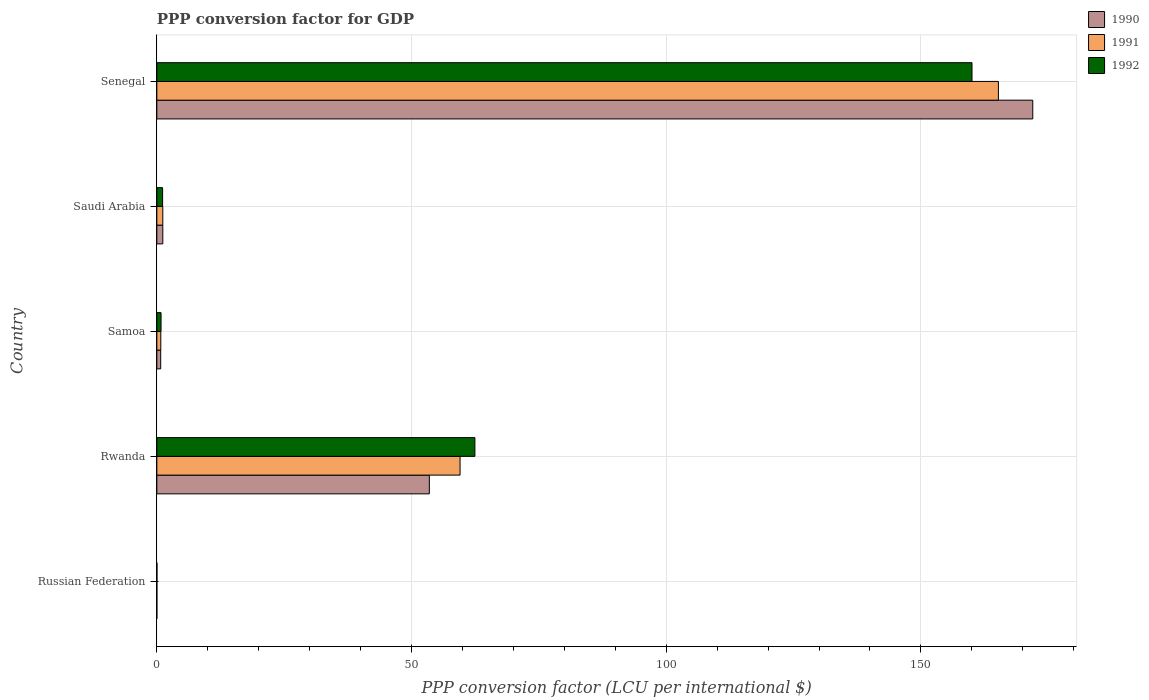How many different coloured bars are there?
Your response must be concise. 3. How many groups of bars are there?
Ensure brevity in your answer.  5. Are the number of bars per tick equal to the number of legend labels?
Your response must be concise. Yes. Are the number of bars on each tick of the Y-axis equal?
Make the answer very short. Yes. What is the label of the 1st group of bars from the top?
Provide a short and direct response. Senegal. What is the PPP conversion factor for GDP in 1991 in Saudi Arabia?
Make the answer very short. 1.17. Across all countries, what is the maximum PPP conversion factor for GDP in 1990?
Your response must be concise. 171.97. Across all countries, what is the minimum PPP conversion factor for GDP in 1991?
Ensure brevity in your answer.  0. In which country was the PPP conversion factor for GDP in 1992 maximum?
Provide a succinct answer. Senegal. In which country was the PPP conversion factor for GDP in 1991 minimum?
Your answer should be compact. Russian Federation. What is the total PPP conversion factor for GDP in 1992 in the graph?
Provide a succinct answer. 224.46. What is the difference between the PPP conversion factor for GDP in 1990 in Saudi Arabia and that in Senegal?
Your answer should be compact. -170.8. What is the difference between the PPP conversion factor for GDP in 1990 in Russian Federation and the PPP conversion factor for GDP in 1992 in Rwanda?
Keep it short and to the point. -62.44. What is the average PPP conversion factor for GDP in 1991 per country?
Provide a short and direct response. 45.34. What is the difference between the PPP conversion factor for GDP in 1992 and PPP conversion factor for GDP in 1990 in Rwanda?
Offer a terse response. 8.94. What is the ratio of the PPP conversion factor for GDP in 1990 in Russian Federation to that in Samoa?
Your response must be concise. 0. What is the difference between the highest and the second highest PPP conversion factor for GDP in 1992?
Give a very brief answer. 97.6. What is the difference between the highest and the lowest PPP conversion factor for GDP in 1990?
Offer a very short reply. 171.97. In how many countries, is the PPP conversion factor for GDP in 1990 greater than the average PPP conversion factor for GDP in 1990 taken over all countries?
Provide a succinct answer. 2. Is the sum of the PPP conversion factor for GDP in 1991 in Russian Federation and Senegal greater than the maximum PPP conversion factor for GDP in 1992 across all countries?
Your answer should be compact. Yes. What does the 3rd bar from the top in Samoa represents?
Your response must be concise. 1990. What does the 1st bar from the bottom in Senegal represents?
Provide a succinct answer. 1990. Is it the case that in every country, the sum of the PPP conversion factor for GDP in 1991 and PPP conversion factor for GDP in 1992 is greater than the PPP conversion factor for GDP in 1990?
Offer a terse response. Yes. How many bars are there?
Offer a very short reply. 15. How many countries are there in the graph?
Keep it short and to the point. 5. What is the difference between two consecutive major ticks on the X-axis?
Ensure brevity in your answer.  50. Are the values on the major ticks of X-axis written in scientific E-notation?
Ensure brevity in your answer.  No. Does the graph contain grids?
Provide a succinct answer. Yes. How are the legend labels stacked?
Make the answer very short. Vertical. What is the title of the graph?
Provide a short and direct response. PPP conversion factor for GDP. What is the label or title of the X-axis?
Ensure brevity in your answer.  PPP conversion factor (LCU per international $). What is the label or title of the Y-axis?
Provide a succinct answer. Country. What is the PPP conversion factor (LCU per international $) in 1990 in Russian Federation?
Make the answer very short. 0. What is the PPP conversion factor (LCU per international $) in 1991 in Russian Federation?
Provide a succinct answer. 0. What is the PPP conversion factor (LCU per international $) in 1992 in Russian Federation?
Provide a succinct answer. 0.02. What is the PPP conversion factor (LCU per international $) of 1990 in Rwanda?
Provide a short and direct response. 53.5. What is the PPP conversion factor (LCU per international $) in 1991 in Rwanda?
Keep it short and to the point. 59.53. What is the PPP conversion factor (LCU per international $) in 1992 in Rwanda?
Keep it short and to the point. 62.44. What is the PPP conversion factor (LCU per international $) in 1990 in Samoa?
Offer a terse response. 0.76. What is the PPP conversion factor (LCU per international $) of 1991 in Samoa?
Your response must be concise. 0.78. What is the PPP conversion factor (LCU per international $) of 1992 in Samoa?
Make the answer very short. 0.82. What is the PPP conversion factor (LCU per international $) of 1990 in Saudi Arabia?
Your response must be concise. 1.17. What is the PPP conversion factor (LCU per international $) in 1991 in Saudi Arabia?
Offer a terse response. 1.17. What is the PPP conversion factor (LCU per international $) in 1992 in Saudi Arabia?
Offer a very short reply. 1.13. What is the PPP conversion factor (LCU per international $) in 1990 in Senegal?
Offer a very short reply. 171.97. What is the PPP conversion factor (LCU per international $) in 1991 in Senegal?
Your answer should be compact. 165.22. What is the PPP conversion factor (LCU per international $) of 1992 in Senegal?
Make the answer very short. 160.04. Across all countries, what is the maximum PPP conversion factor (LCU per international $) of 1990?
Your response must be concise. 171.97. Across all countries, what is the maximum PPP conversion factor (LCU per international $) in 1991?
Offer a very short reply. 165.22. Across all countries, what is the maximum PPP conversion factor (LCU per international $) of 1992?
Your answer should be compact. 160.04. Across all countries, what is the minimum PPP conversion factor (LCU per international $) in 1990?
Your answer should be very brief. 0. Across all countries, what is the minimum PPP conversion factor (LCU per international $) of 1991?
Give a very brief answer. 0. Across all countries, what is the minimum PPP conversion factor (LCU per international $) in 1992?
Give a very brief answer. 0.02. What is the total PPP conversion factor (LCU per international $) in 1990 in the graph?
Provide a short and direct response. 227.39. What is the total PPP conversion factor (LCU per international $) of 1991 in the graph?
Ensure brevity in your answer.  226.7. What is the total PPP conversion factor (LCU per international $) of 1992 in the graph?
Offer a terse response. 224.46. What is the difference between the PPP conversion factor (LCU per international $) of 1990 in Russian Federation and that in Rwanda?
Give a very brief answer. -53.5. What is the difference between the PPP conversion factor (LCU per international $) of 1991 in Russian Federation and that in Rwanda?
Provide a short and direct response. -59.53. What is the difference between the PPP conversion factor (LCU per international $) in 1992 in Russian Federation and that in Rwanda?
Ensure brevity in your answer.  -62.42. What is the difference between the PPP conversion factor (LCU per international $) of 1990 in Russian Federation and that in Samoa?
Ensure brevity in your answer.  -0.76. What is the difference between the PPP conversion factor (LCU per international $) of 1991 in Russian Federation and that in Samoa?
Offer a terse response. -0.78. What is the difference between the PPP conversion factor (LCU per international $) of 1992 in Russian Federation and that in Samoa?
Offer a terse response. -0.81. What is the difference between the PPP conversion factor (LCU per international $) of 1990 in Russian Federation and that in Saudi Arabia?
Give a very brief answer. -1.17. What is the difference between the PPP conversion factor (LCU per international $) of 1991 in Russian Federation and that in Saudi Arabia?
Make the answer very short. -1.17. What is the difference between the PPP conversion factor (LCU per international $) in 1992 in Russian Federation and that in Saudi Arabia?
Your response must be concise. -1.11. What is the difference between the PPP conversion factor (LCU per international $) of 1990 in Russian Federation and that in Senegal?
Make the answer very short. -171.97. What is the difference between the PPP conversion factor (LCU per international $) of 1991 in Russian Federation and that in Senegal?
Make the answer very short. -165.22. What is the difference between the PPP conversion factor (LCU per international $) of 1992 in Russian Federation and that in Senegal?
Offer a terse response. -160.02. What is the difference between the PPP conversion factor (LCU per international $) in 1990 in Rwanda and that in Samoa?
Offer a very short reply. 52.74. What is the difference between the PPP conversion factor (LCU per international $) in 1991 in Rwanda and that in Samoa?
Provide a succinct answer. 58.75. What is the difference between the PPP conversion factor (LCU per international $) of 1992 in Rwanda and that in Samoa?
Provide a succinct answer. 61.62. What is the difference between the PPP conversion factor (LCU per international $) in 1990 in Rwanda and that in Saudi Arabia?
Your answer should be compact. 52.33. What is the difference between the PPP conversion factor (LCU per international $) in 1991 in Rwanda and that in Saudi Arabia?
Your answer should be compact. 58.36. What is the difference between the PPP conversion factor (LCU per international $) of 1992 in Rwanda and that in Saudi Arabia?
Give a very brief answer. 61.31. What is the difference between the PPP conversion factor (LCU per international $) of 1990 in Rwanda and that in Senegal?
Your response must be concise. -118.47. What is the difference between the PPP conversion factor (LCU per international $) in 1991 in Rwanda and that in Senegal?
Offer a very short reply. -105.69. What is the difference between the PPP conversion factor (LCU per international $) in 1992 in Rwanda and that in Senegal?
Provide a short and direct response. -97.6. What is the difference between the PPP conversion factor (LCU per international $) of 1990 in Samoa and that in Saudi Arabia?
Offer a very short reply. -0.41. What is the difference between the PPP conversion factor (LCU per international $) of 1991 in Samoa and that in Saudi Arabia?
Keep it short and to the point. -0.39. What is the difference between the PPP conversion factor (LCU per international $) in 1992 in Samoa and that in Saudi Arabia?
Give a very brief answer. -0.31. What is the difference between the PPP conversion factor (LCU per international $) in 1990 in Samoa and that in Senegal?
Offer a terse response. -171.21. What is the difference between the PPP conversion factor (LCU per international $) of 1991 in Samoa and that in Senegal?
Offer a terse response. -164.45. What is the difference between the PPP conversion factor (LCU per international $) in 1992 in Samoa and that in Senegal?
Provide a short and direct response. -159.21. What is the difference between the PPP conversion factor (LCU per international $) in 1990 in Saudi Arabia and that in Senegal?
Your answer should be very brief. -170.8. What is the difference between the PPP conversion factor (LCU per international $) of 1991 in Saudi Arabia and that in Senegal?
Your response must be concise. -164.05. What is the difference between the PPP conversion factor (LCU per international $) of 1992 in Saudi Arabia and that in Senegal?
Your answer should be compact. -158.91. What is the difference between the PPP conversion factor (LCU per international $) of 1990 in Russian Federation and the PPP conversion factor (LCU per international $) of 1991 in Rwanda?
Offer a terse response. -59.53. What is the difference between the PPP conversion factor (LCU per international $) in 1990 in Russian Federation and the PPP conversion factor (LCU per international $) in 1992 in Rwanda?
Provide a short and direct response. -62.44. What is the difference between the PPP conversion factor (LCU per international $) of 1991 in Russian Federation and the PPP conversion factor (LCU per international $) of 1992 in Rwanda?
Your response must be concise. -62.44. What is the difference between the PPP conversion factor (LCU per international $) of 1990 in Russian Federation and the PPP conversion factor (LCU per international $) of 1991 in Samoa?
Offer a very short reply. -0.78. What is the difference between the PPP conversion factor (LCU per international $) in 1990 in Russian Federation and the PPP conversion factor (LCU per international $) in 1992 in Samoa?
Give a very brief answer. -0.82. What is the difference between the PPP conversion factor (LCU per international $) in 1991 in Russian Federation and the PPP conversion factor (LCU per international $) in 1992 in Samoa?
Keep it short and to the point. -0.82. What is the difference between the PPP conversion factor (LCU per international $) in 1990 in Russian Federation and the PPP conversion factor (LCU per international $) in 1991 in Saudi Arabia?
Make the answer very short. -1.17. What is the difference between the PPP conversion factor (LCU per international $) in 1990 in Russian Federation and the PPP conversion factor (LCU per international $) in 1992 in Saudi Arabia?
Offer a terse response. -1.13. What is the difference between the PPP conversion factor (LCU per international $) of 1991 in Russian Federation and the PPP conversion factor (LCU per international $) of 1992 in Saudi Arabia?
Your response must be concise. -1.13. What is the difference between the PPP conversion factor (LCU per international $) of 1990 in Russian Federation and the PPP conversion factor (LCU per international $) of 1991 in Senegal?
Give a very brief answer. -165.22. What is the difference between the PPP conversion factor (LCU per international $) in 1990 in Russian Federation and the PPP conversion factor (LCU per international $) in 1992 in Senegal?
Ensure brevity in your answer.  -160.04. What is the difference between the PPP conversion factor (LCU per international $) in 1991 in Russian Federation and the PPP conversion factor (LCU per international $) in 1992 in Senegal?
Offer a terse response. -160.04. What is the difference between the PPP conversion factor (LCU per international $) in 1990 in Rwanda and the PPP conversion factor (LCU per international $) in 1991 in Samoa?
Offer a very short reply. 52.72. What is the difference between the PPP conversion factor (LCU per international $) in 1990 in Rwanda and the PPP conversion factor (LCU per international $) in 1992 in Samoa?
Keep it short and to the point. 52.67. What is the difference between the PPP conversion factor (LCU per international $) of 1991 in Rwanda and the PPP conversion factor (LCU per international $) of 1992 in Samoa?
Your answer should be very brief. 58.71. What is the difference between the PPP conversion factor (LCU per international $) of 1990 in Rwanda and the PPP conversion factor (LCU per international $) of 1991 in Saudi Arabia?
Your answer should be compact. 52.33. What is the difference between the PPP conversion factor (LCU per international $) of 1990 in Rwanda and the PPP conversion factor (LCU per international $) of 1992 in Saudi Arabia?
Provide a succinct answer. 52.37. What is the difference between the PPP conversion factor (LCU per international $) in 1991 in Rwanda and the PPP conversion factor (LCU per international $) in 1992 in Saudi Arabia?
Ensure brevity in your answer.  58.4. What is the difference between the PPP conversion factor (LCU per international $) in 1990 in Rwanda and the PPP conversion factor (LCU per international $) in 1991 in Senegal?
Provide a succinct answer. -111.72. What is the difference between the PPP conversion factor (LCU per international $) of 1990 in Rwanda and the PPP conversion factor (LCU per international $) of 1992 in Senegal?
Ensure brevity in your answer.  -106.54. What is the difference between the PPP conversion factor (LCU per international $) of 1991 in Rwanda and the PPP conversion factor (LCU per international $) of 1992 in Senegal?
Your answer should be very brief. -100.51. What is the difference between the PPP conversion factor (LCU per international $) in 1990 in Samoa and the PPP conversion factor (LCU per international $) in 1991 in Saudi Arabia?
Provide a short and direct response. -0.41. What is the difference between the PPP conversion factor (LCU per international $) of 1990 in Samoa and the PPP conversion factor (LCU per international $) of 1992 in Saudi Arabia?
Make the answer very short. -0.38. What is the difference between the PPP conversion factor (LCU per international $) of 1991 in Samoa and the PPP conversion factor (LCU per international $) of 1992 in Saudi Arabia?
Keep it short and to the point. -0.36. What is the difference between the PPP conversion factor (LCU per international $) in 1990 in Samoa and the PPP conversion factor (LCU per international $) in 1991 in Senegal?
Provide a short and direct response. -164.47. What is the difference between the PPP conversion factor (LCU per international $) of 1990 in Samoa and the PPP conversion factor (LCU per international $) of 1992 in Senegal?
Your answer should be very brief. -159.28. What is the difference between the PPP conversion factor (LCU per international $) in 1991 in Samoa and the PPP conversion factor (LCU per international $) in 1992 in Senegal?
Provide a short and direct response. -159.26. What is the difference between the PPP conversion factor (LCU per international $) in 1990 in Saudi Arabia and the PPP conversion factor (LCU per international $) in 1991 in Senegal?
Keep it short and to the point. -164.05. What is the difference between the PPP conversion factor (LCU per international $) in 1990 in Saudi Arabia and the PPP conversion factor (LCU per international $) in 1992 in Senegal?
Make the answer very short. -158.87. What is the difference between the PPP conversion factor (LCU per international $) in 1991 in Saudi Arabia and the PPP conversion factor (LCU per international $) in 1992 in Senegal?
Offer a terse response. -158.87. What is the average PPP conversion factor (LCU per international $) in 1990 per country?
Your answer should be very brief. 45.48. What is the average PPP conversion factor (LCU per international $) of 1991 per country?
Keep it short and to the point. 45.34. What is the average PPP conversion factor (LCU per international $) of 1992 per country?
Keep it short and to the point. 44.89. What is the difference between the PPP conversion factor (LCU per international $) in 1990 and PPP conversion factor (LCU per international $) in 1991 in Russian Federation?
Offer a terse response. -0. What is the difference between the PPP conversion factor (LCU per international $) in 1990 and PPP conversion factor (LCU per international $) in 1992 in Russian Federation?
Offer a terse response. -0.02. What is the difference between the PPP conversion factor (LCU per international $) in 1991 and PPP conversion factor (LCU per international $) in 1992 in Russian Federation?
Offer a terse response. -0.02. What is the difference between the PPP conversion factor (LCU per international $) of 1990 and PPP conversion factor (LCU per international $) of 1991 in Rwanda?
Provide a short and direct response. -6.03. What is the difference between the PPP conversion factor (LCU per international $) in 1990 and PPP conversion factor (LCU per international $) in 1992 in Rwanda?
Ensure brevity in your answer.  -8.94. What is the difference between the PPP conversion factor (LCU per international $) of 1991 and PPP conversion factor (LCU per international $) of 1992 in Rwanda?
Your answer should be compact. -2.91. What is the difference between the PPP conversion factor (LCU per international $) in 1990 and PPP conversion factor (LCU per international $) in 1991 in Samoa?
Your response must be concise. -0.02. What is the difference between the PPP conversion factor (LCU per international $) in 1990 and PPP conversion factor (LCU per international $) in 1992 in Samoa?
Provide a succinct answer. -0.07. What is the difference between the PPP conversion factor (LCU per international $) of 1991 and PPP conversion factor (LCU per international $) of 1992 in Samoa?
Ensure brevity in your answer.  -0.05. What is the difference between the PPP conversion factor (LCU per international $) of 1990 and PPP conversion factor (LCU per international $) of 1991 in Saudi Arabia?
Ensure brevity in your answer.  0. What is the difference between the PPP conversion factor (LCU per international $) of 1990 and PPP conversion factor (LCU per international $) of 1992 in Saudi Arabia?
Give a very brief answer. 0.04. What is the difference between the PPP conversion factor (LCU per international $) of 1991 and PPP conversion factor (LCU per international $) of 1992 in Saudi Arabia?
Offer a very short reply. 0.04. What is the difference between the PPP conversion factor (LCU per international $) of 1990 and PPP conversion factor (LCU per international $) of 1991 in Senegal?
Give a very brief answer. 6.74. What is the difference between the PPP conversion factor (LCU per international $) of 1990 and PPP conversion factor (LCU per international $) of 1992 in Senegal?
Give a very brief answer. 11.93. What is the difference between the PPP conversion factor (LCU per international $) in 1991 and PPP conversion factor (LCU per international $) in 1992 in Senegal?
Offer a very short reply. 5.18. What is the ratio of the PPP conversion factor (LCU per international $) of 1990 in Russian Federation to that in Samoa?
Provide a succinct answer. 0. What is the ratio of the PPP conversion factor (LCU per international $) in 1991 in Russian Federation to that in Samoa?
Ensure brevity in your answer.  0. What is the ratio of the PPP conversion factor (LCU per international $) of 1992 in Russian Federation to that in Samoa?
Provide a succinct answer. 0.02. What is the ratio of the PPP conversion factor (LCU per international $) of 1990 in Russian Federation to that in Saudi Arabia?
Provide a succinct answer. 0. What is the ratio of the PPP conversion factor (LCU per international $) of 1991 in Russian Federation to that in Saudi Arabia?
Provide a short and direct response. 0. What is the ratio of the PPP conversion factor (LCU per international $) of 1992 in Russian Federation to that in Saudi Arabia?
Keep it short and to the point. 0.02. What is the ratio of the PPP conversion factor (LCU per international $) of 1991 in Russian Federation to that in Senegal?
Your answer should be compact. 0. What is the ratio of the PPP conversion factor (LCU per international $) of 1992 in Russian Federation to that in Senegal?
Your answer should be compact. 0. What is the ratio of the PPP conversion factor (LCU per international $) of 1990 in Rwanda to that in Samoa?
Your answer should be very brief. 70.74. What is the ratio of the PPP conversion factor (LCU per international $) in 1991 in Rwanda to that in Samoa?
Make the answer very short. 76.65. What is the ratio of the PPP conversion factor (LCU per international $) in 1992 in Rwanda to that in Samoa?
Provide a short and direct response. 75.74. What is the ratio of the PPP conversion factor (LCU per international $) of 1990 in Rwanda to that in Saudi Arabia?
Offer a very short reply. 45.72. What is the ratio of the PPP conversion factor (LCU per international $) in 1991 in Rwanda to that in Saudi Arabia?
Provide a short and direct response. 51. What is the ratio of the PPP conversion factor (LCU per international $) in 1992 in Rwanda to that in Saudi Arabia?
Provide a succinct answer. 55.16. What is the ratio of the PPP conversion factor (LCU per international $) of 1990 in Rwanda to that in Senegal?
Provide a succinct answer. 0.31. What is the ratio of the PPP conversion factor (LCU per international $) in 1991 in Rwanda to that in Senegal?
Provide a succinct answer. 0.36. What is the ratio of the PPP conversion factor (LCU per international $) in 1992 in Rwanda to that in Senegal?
Offer a very short reply. 0.39. What is the ratio of the PPP conversion factor (LCU per international $) of 1990 in Samoa to that in Saudi Arabia?
Make the answer very short. 0.65. What is the ratio of the PPP conversion factor (LCU per international $) in 1991 in Samoa to that in Saudi Arabia?
Ensure brevity in your answer.  0.67. What is the ratio of the PPP conversion factor (LCU per international $) in 1992 in Samoa to that in Saudi Arabia?
Give a very brief answer. 0.73. What is the ratio of the PPP conversion factor (LCU per international $) in 1990 in Samoa to that in Senegal?
Give a very brief answer. 0. What is the ratio of the PPP conversion factor (LCU per international $) in 1991 in Samoa to that in Senegal?
Keep it short and to the point. 0. What is the ratio of the PPP conversion factor (LCU per international $) of 1992 in Samoa to that in Senegal?
Provide a succinct answer. 0.01. What is the ratio of the PPP conversion factor (LCU per international $) in 1990 in Saudi Arabia to that in Senegal?
Provide a short and direct response. 0.01. What is the ratio of the PPP conversion factor (LCU per international $) in 1991 in Saudi Arabia to that in Senegal?
Ensure brevity in your answer.  0.01. What is the ratio of the PPP conversion factor (LCU per international $) of 1992 in Saudi Arabia to that in Senegal?
Ensure brevity in your answer.  0.01. What is the difference between the highest and the second highest PPP conversion factor (LCU per international $) of 1990?
Make the answer very short. 118.47. What is the difference between the highest and the second highest PPP conversion factor (LCU per international $) in 1991?
Ensure brevity in your answer.  105.69. What is the difference between the highest and the second highest PPP conversion factor (LCU per international $) in 1992?
Give a very brief answer. 97.6. What is the difference between the highest and the lowest PPP conversion factor (LCU per international $) of 1990?
Keep it short and to the point. 171.97. What is the difference between the highest and the lowest PPP conversion factor (LCU per international $) in 1991?
Your answer should be compact. 165.22. What is the difference between the highest and the lowest PPP conversion factor (LCU per international $) in 1992?
Keep it short and to the point. 160.02. 